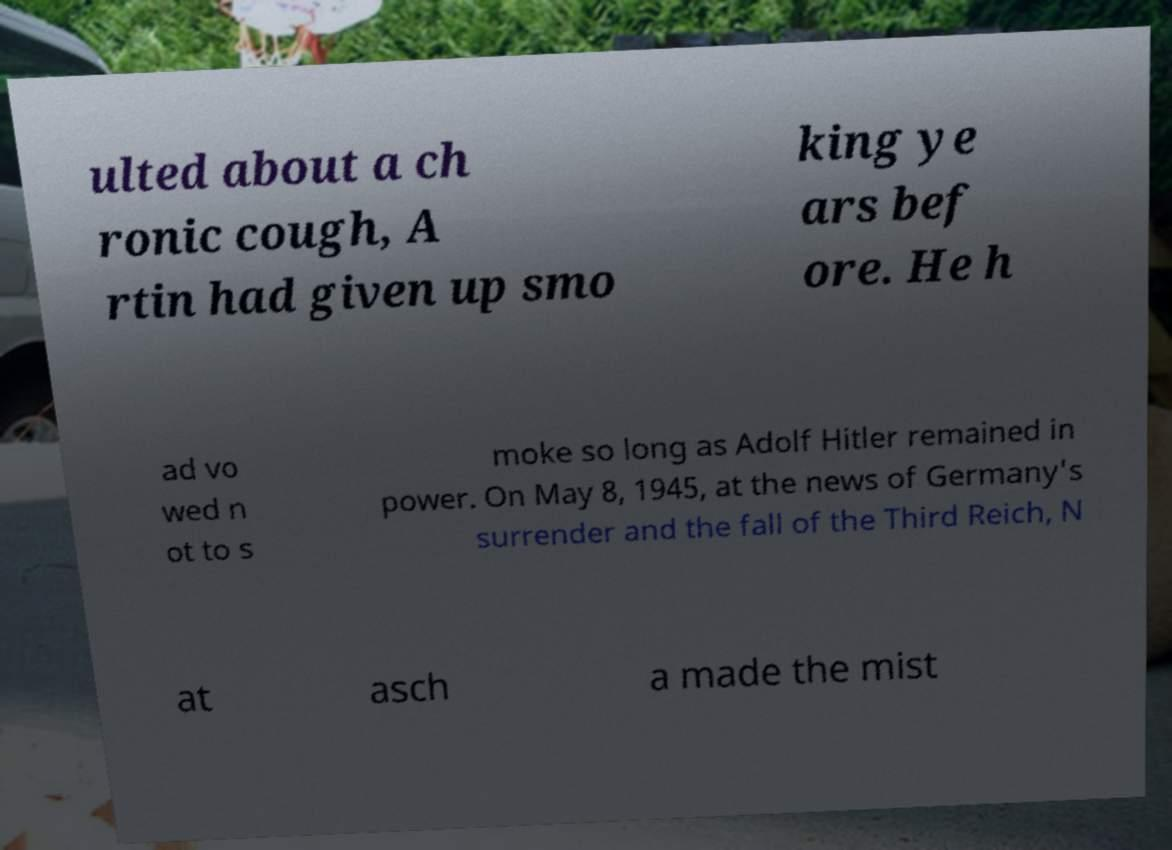There's text embedded in this image that I need extracted. Can you transcribe it verbatim? ulted about a ch ronic cough, A rtin had given up smo king ye ars bef ore. He h ad vo wed n ot to s moke so long as Adolf Hitler remained in power. On May 8, 1945, at the news of Germany's surrender and the fall of the Third Reich, N at asch a made the mist 